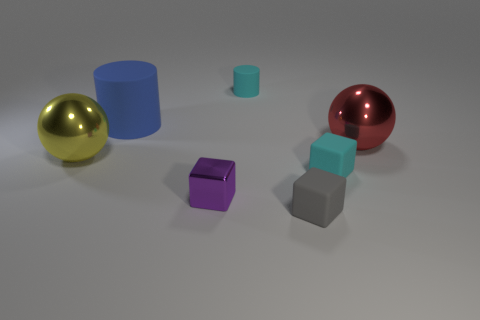How many large rubber things are on the right side of the big thing to the right of the tiny cyan rubber block?
Offer a very short reply. 0. What number of things are spheres that are right of the purple metal object or big things?
Keep it short and to the point. 3. Are there any other things of the same shape as the small gray thing?
Your response must be concise. Yes. The large metal thing behind the metal ball left of the cyan rubber block is what shape?
Give a very brief answer. Sphere. What number of spheres are either big green things or big metal things?
Make the answer very short. 2. What is the material of the cube that is the same color as the tiny matte cylinder?
Ensure brevity in your answer.  Rubber. There is a small object that is on the right side of the tiny gray object; is its shape the same as the purple object in front of the blue object?
Ensure brevity in your answer.  Yes. The matte object that is left of the gray cube and on the right side of the blue rubber cylinder is what color?
Your answer should be compact. Cyan. Does the tiny matte cylinder have the same color as the small matte block that is behind the small purple metal object?
Your answer should be compact. Yes. There is a matte thing that is in front of the cyan cylinder and to the left of the gray matte cube; how big is it?
Give a very brief answer. Large. 